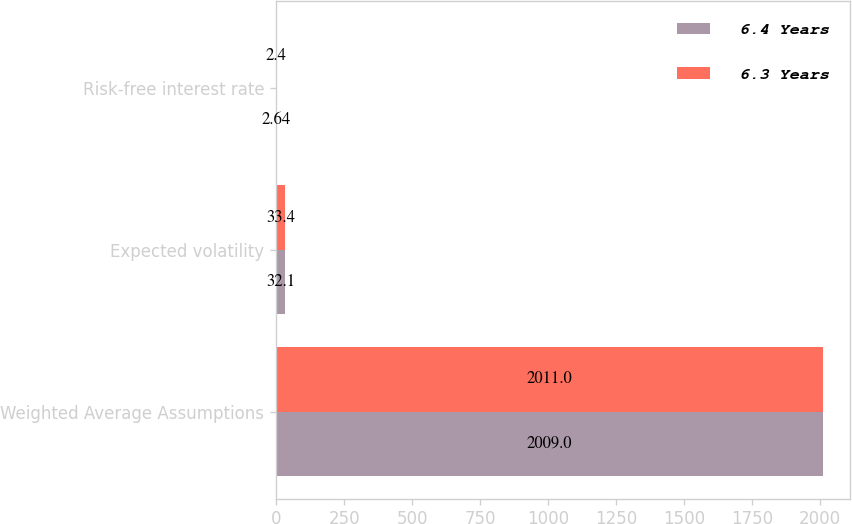Convert chart. <chart><loc_0><loc_0><loc_500><loc_500><stacked_bar_chart><ecel><fcel>Weighted Average Assumptions<fcel>Expected volatility<fcel>Risk-free interest rate<nl><fcel>6.4 Years<fcel>2009<fcel>32.1<fcel>2.64<nl><fcel>6.3 Years<fcel>2011<fcel>33.4<fcel>2.4<nl></chart> 